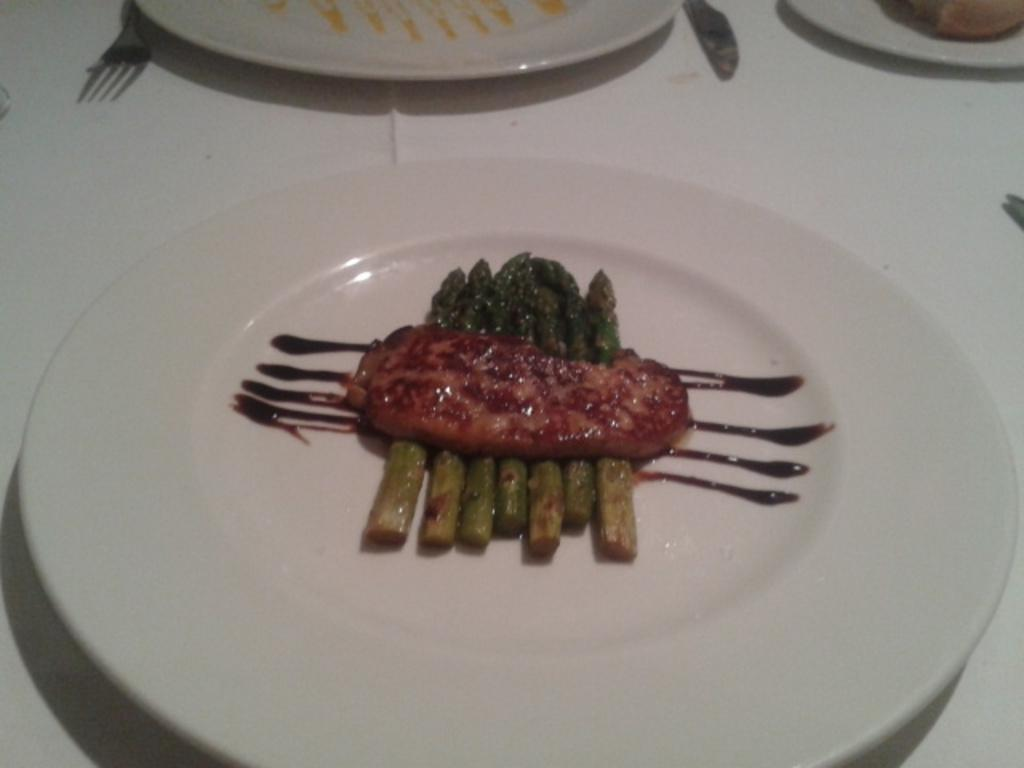What is the color of the surface in the image? The surface in the image is white. What objects are placed on the white surface? There are plates, a knife, and a fork on the white surface. Is there any food visible in the image? Yes, there is a food item on one of the plates. How many beads are scattered on the white surface in the image? There are no beads present on the white surface in the image. What type of station is visible in the image? There is no station present in the image. 